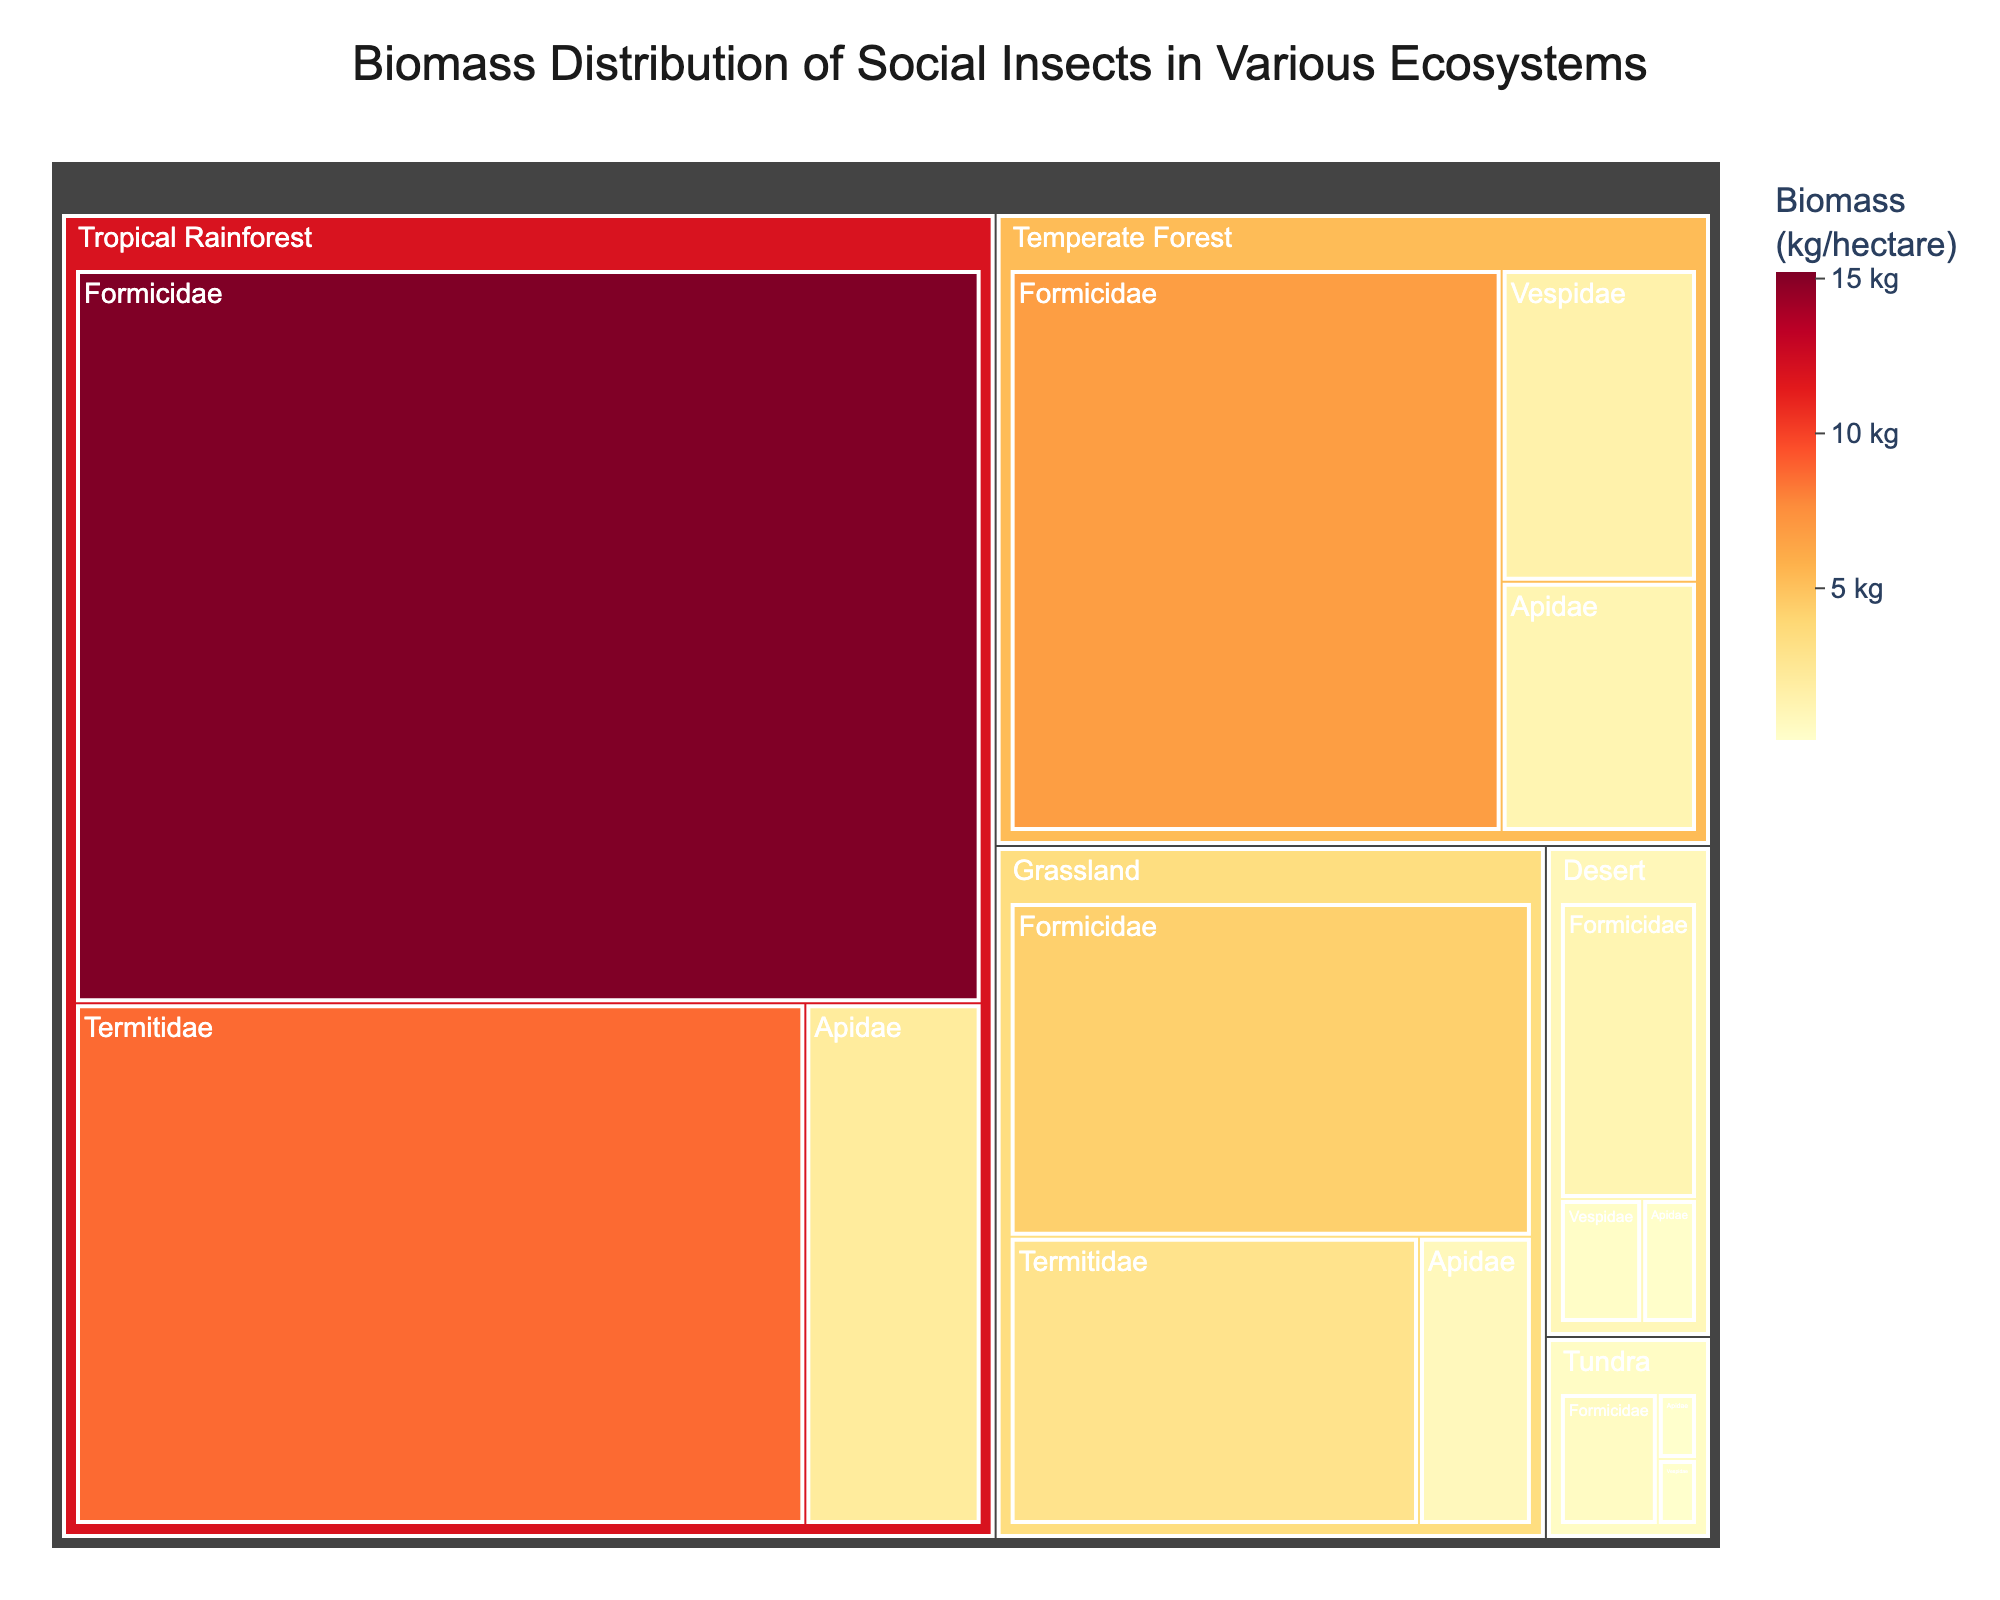What is the title of the treemap? The title of the treemap is located at the top of the figure.
Answer: Biomass Distribution of Social Insects in Various Ecosystems Which family has the highest biomass in Tropical Rainforest? In the Tropical Rainforest section of the treemap, the size of the box and the biomass value indicate the highest biomass.
Answer: Formicidae In which ecosystem is the Apidae family biomass the highest? By comparing the Apidae sections in each ecosystem on the treemap, the largest box indicates the highest biomass.
Answer: Tropical Rainforest Compare the biomass of the Termitidae family in the Grassland and Tropical Rainforest ecosystems. Which one is higher? By looking at the boxes for Termitidae in Grassland and Tropical Rainforest, the larger box represents the higher biomass.
Answer: Tropical Rainforest What's the total biomass of Formicidae across all ecosystems? Add the biomass values of Formicidae in all ecosystems: 15.2 (Tropical Rainforest) + 6.8 (Temperate Forest) + 4.3 (Grassland) + 1.2 (Desert) + 0.5 (Tundra).
Answer: 28.0 kg/hectare Which family has the lowest biomass in Desert? In the Desert section of the treemap, the smallest box and the biomass value indicate the lowest biomass.
Answer: Apidae Calculate the average biomass of Apidae across all ecosystems. Add the biomass values of Apidae in all ecosystems, then divide by the number of ecosystems: (2.1 + 1.2 + 0.8 + 0.2 + 0.1) / 5.
Answer: 0.88 kg/hectare Identify the ecosystem with the lowest overall biomass of social insects. By comparing the total biomass across all families within each ecosystem, the one with the smallest combined biomass has the lowest overall biomass.
Answer: Tundra Which ecosystem has the highest Vespidae biomass? By comparing the Vespidae sections in each ecosystem on the treemap, the largest box indicates the highest biomass.
Answer: Temperate Forest What is the difference in biomass between the Termitidae family in Grassland and Desert? Subtract the biomass value of Termitidae in Desert from the value in Grassland: 2.9 (Grassland) - 0 (Desert).
Answer: 2.9 kg/hectare 